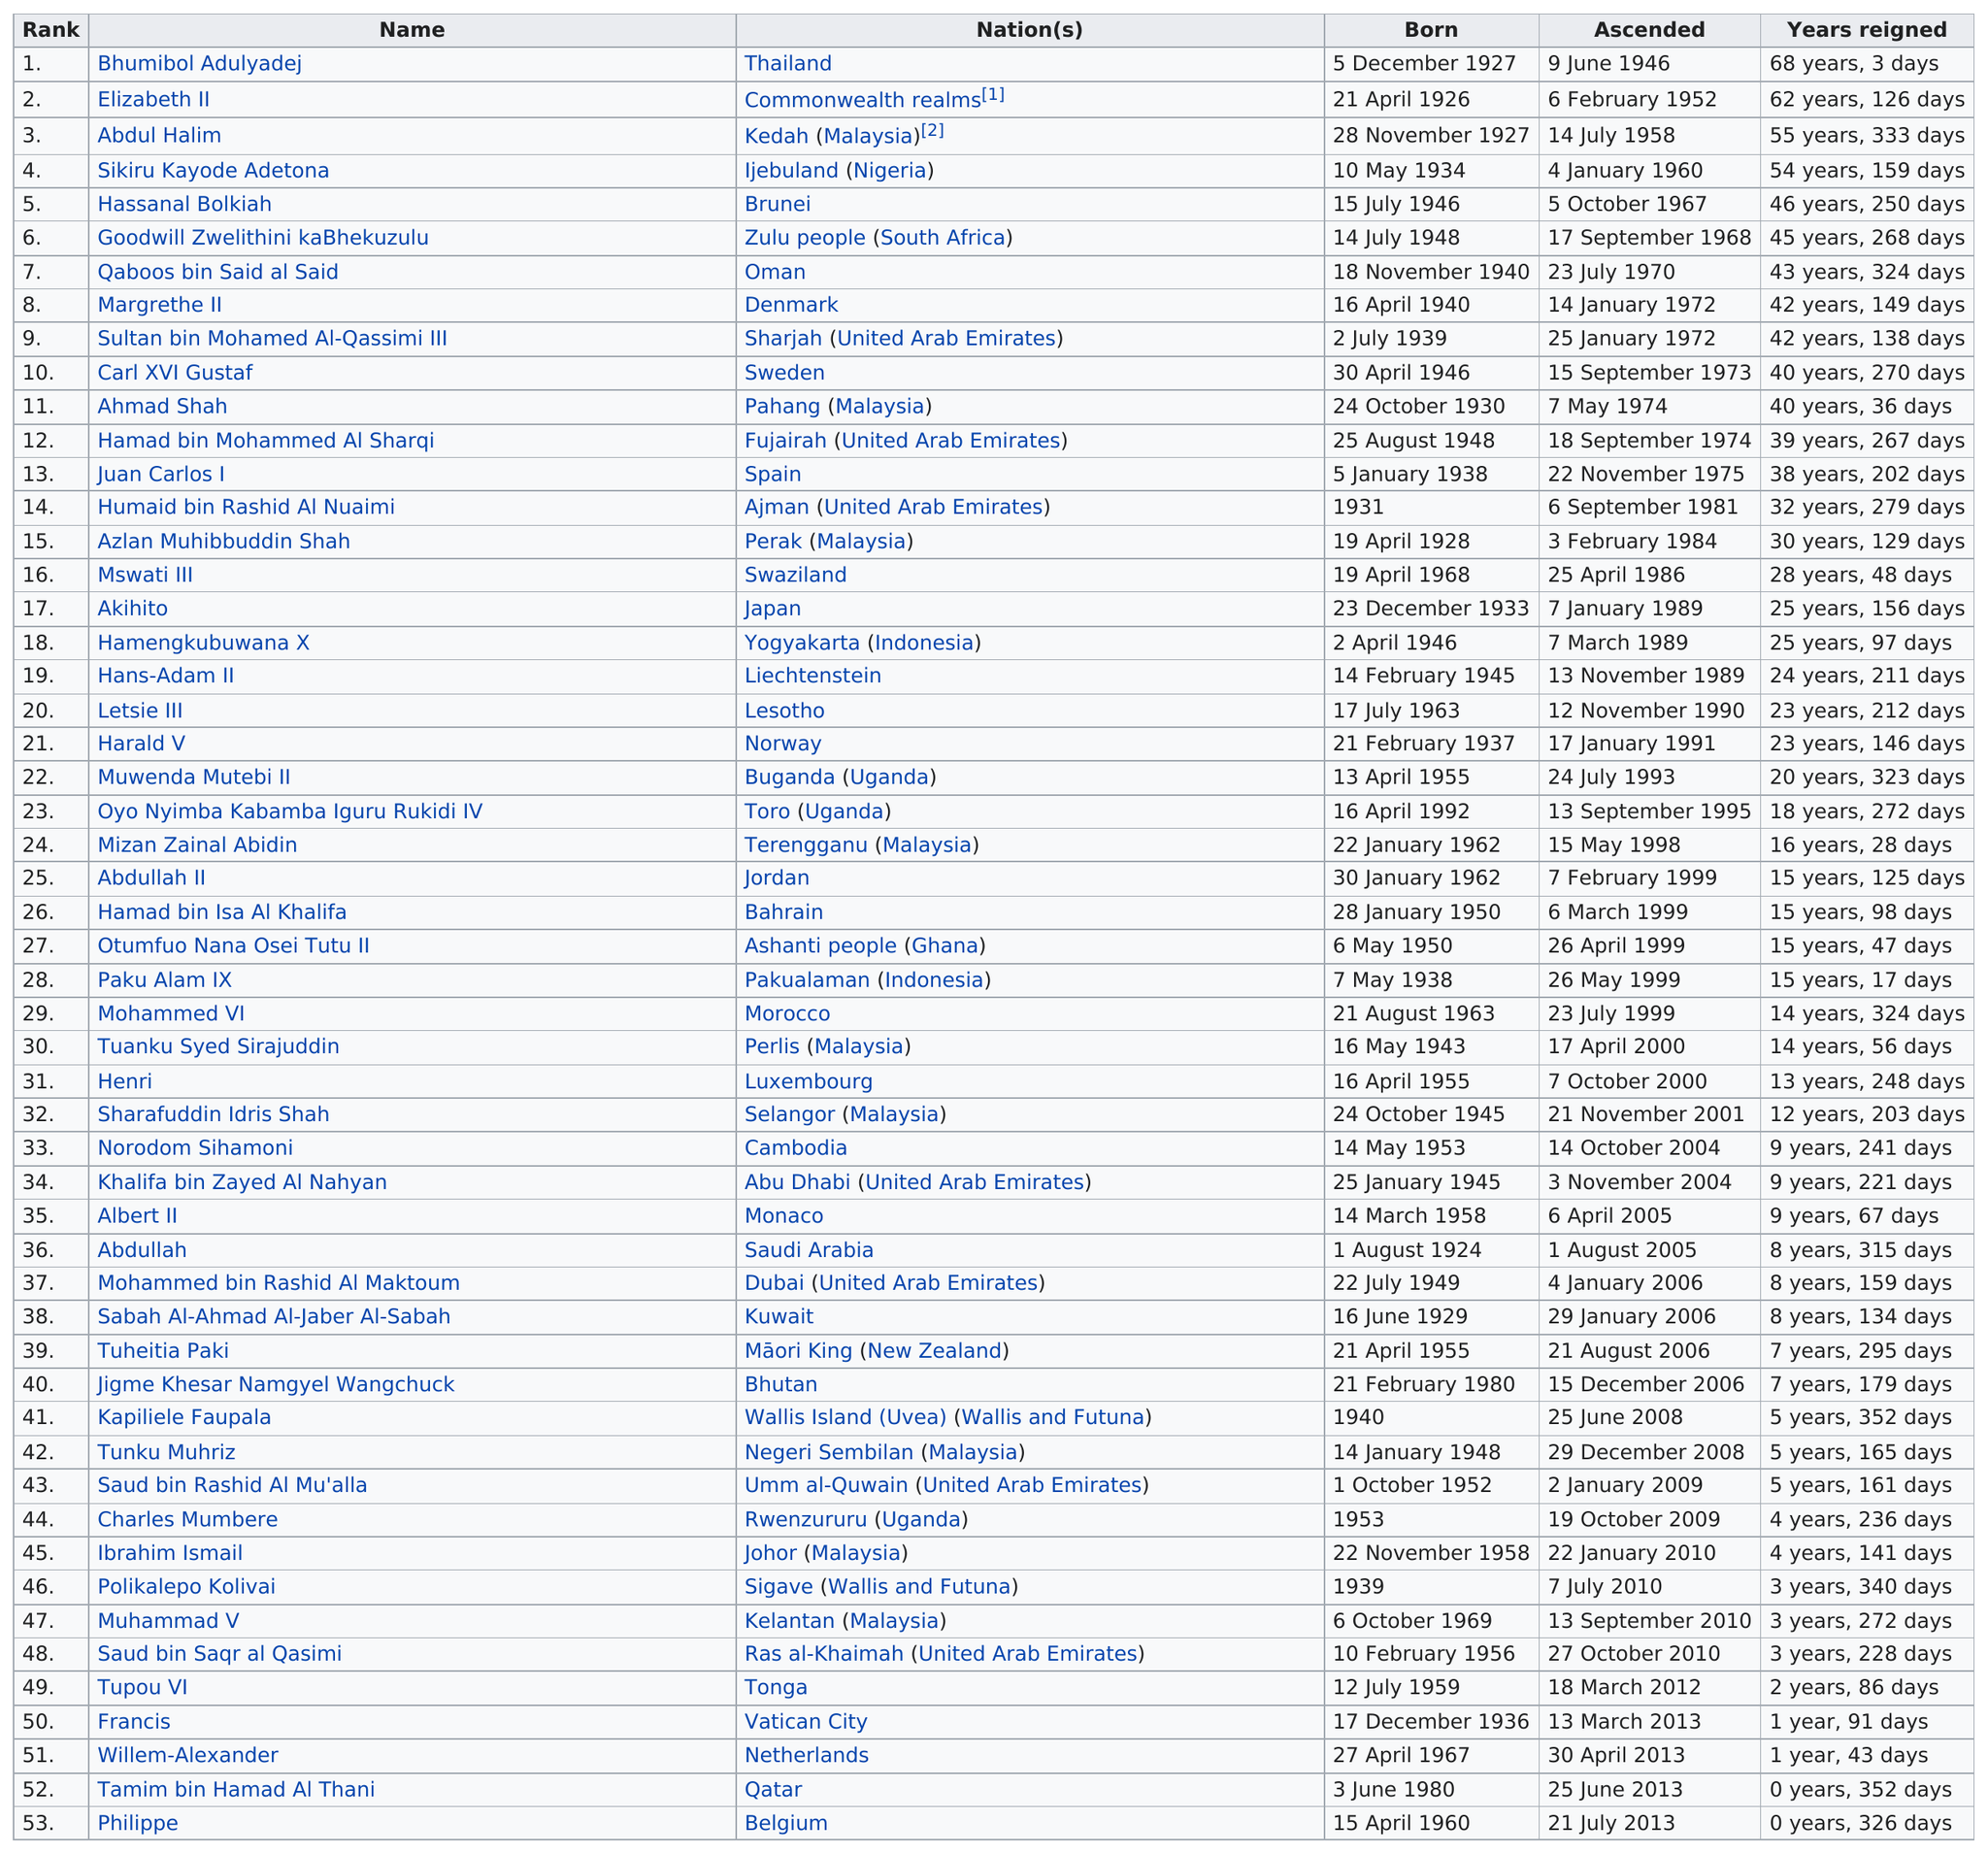Draw attention to some important aspects in this diagram. The monarchs who reigned for more than 50 years are Bhumibol Adulyadej, Elizabeth II, Abdul Halim, and Sikiru Kayode Adetona. Thailand and the Commonwealth Realms have monarchs with the longest and second longest reign, respectively. Out of the monarchs who have reigned for less than one year, two have done so. The current top three longest-enthroned monarchs in existence are Bhumibol Adulyadej, Elizabeth II, and Abdul Halim. There were four monarchs who ascended the throne in 2010. 